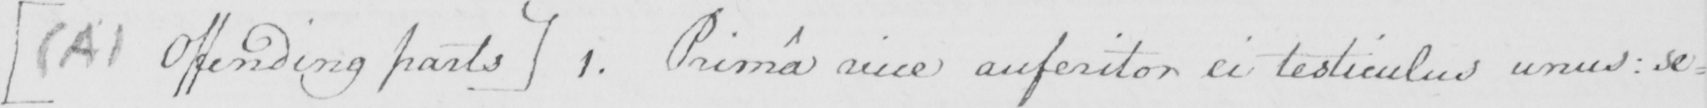Transcribe the text shown in this historical manuscript line. [  ( A )  Offending parts ]  1 . Prima vice auferitor ei testiculus unus :  se= 